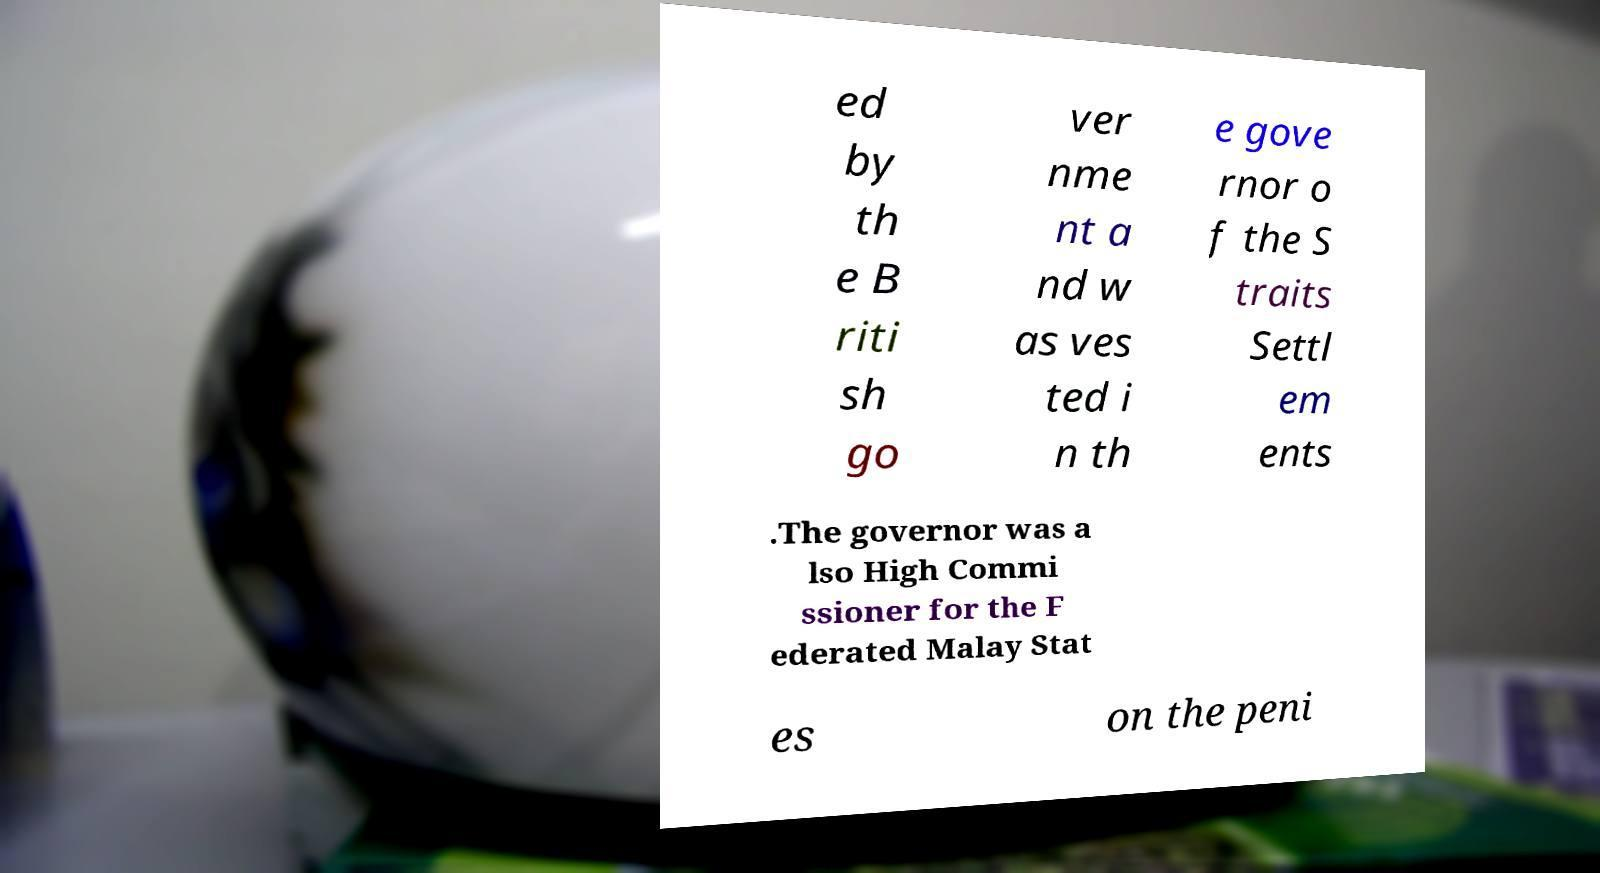For documentation purposes, I need the text within this image transcribed. Could you provide that? ed by th e B riti sh go ver nme nt a nd w as ves ted i n th e gove rnor o f the S traits Settl em ents .The governor was a lso High Commi ssioner for the F ederated Malay Stat es on the peni 